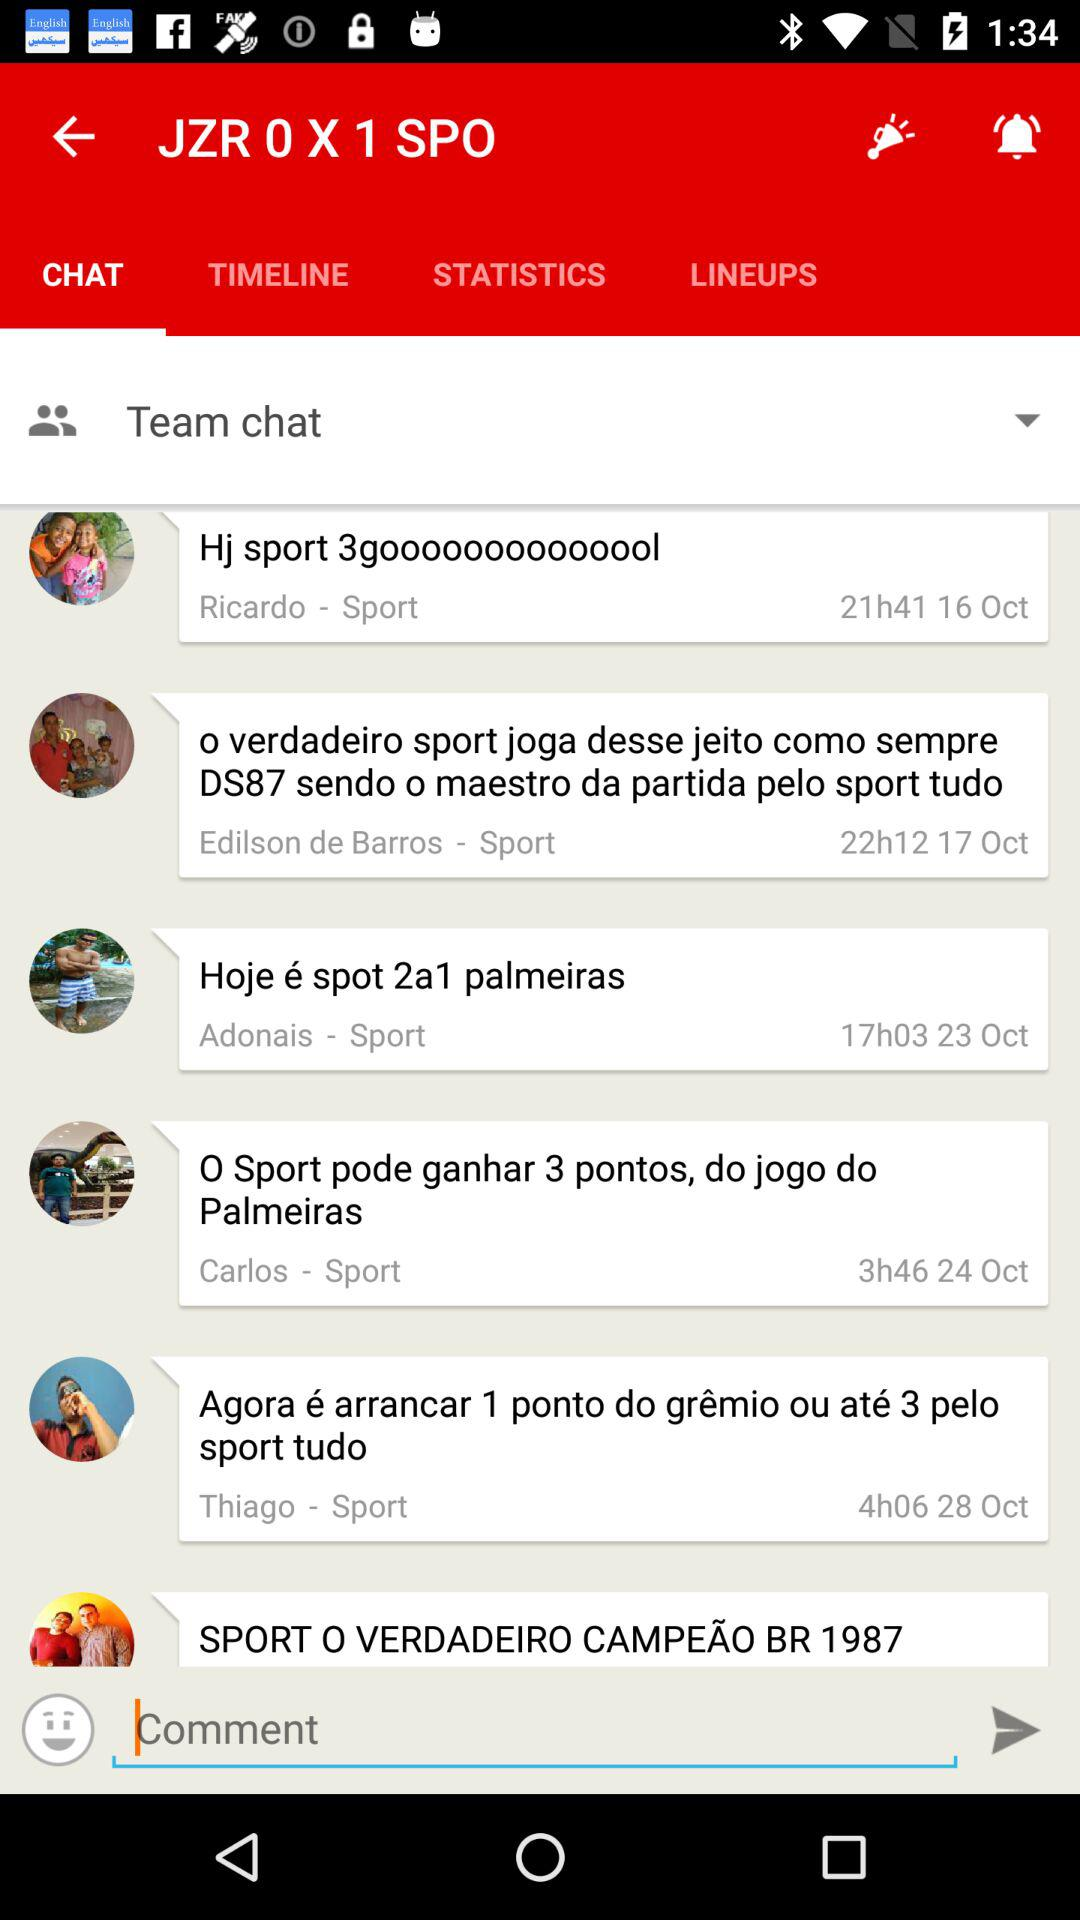How many hours ago was the most recent message sent?
Answer the question using a single word or phrase. 4h06 